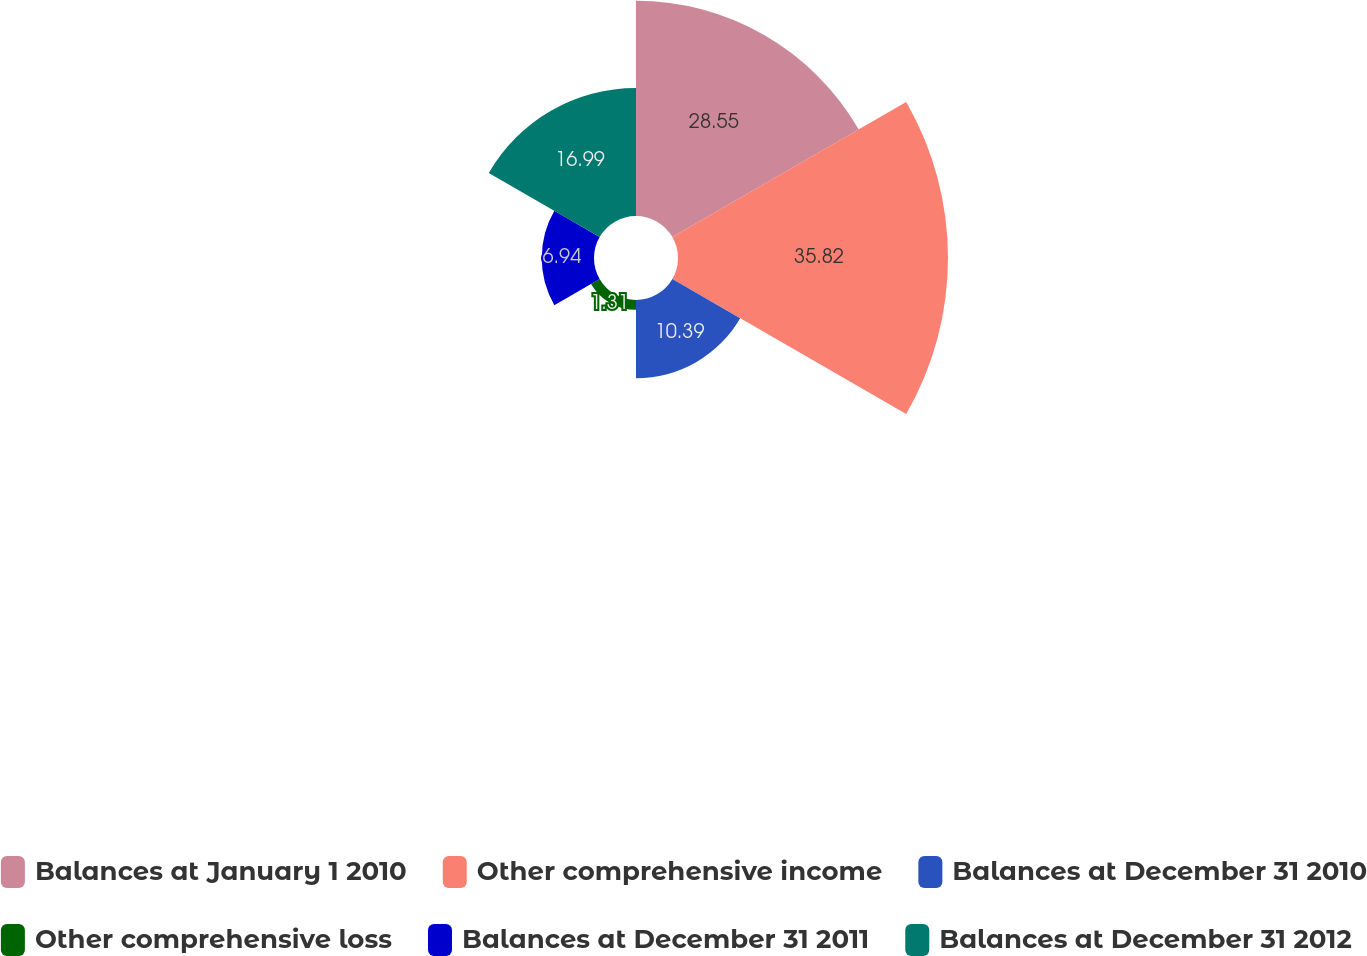Convert chart. <chart><loc_0><loc_0><loc_500><loc_500><pie_chart><fcel>Balances at January 1 2010<fcel>Other comprehensive income<fcel>Balances at December 31 2010<fcel>Other comprehensive loss<fcel>Balances at December 31 2011<fcel>Balances at December 31 2012<nl><fcel>28.55%<fcel>35.83%<fcel>10.39%<fcel>1.31%<fcel>6.94%<fcel>16.99%<nl></chart> 